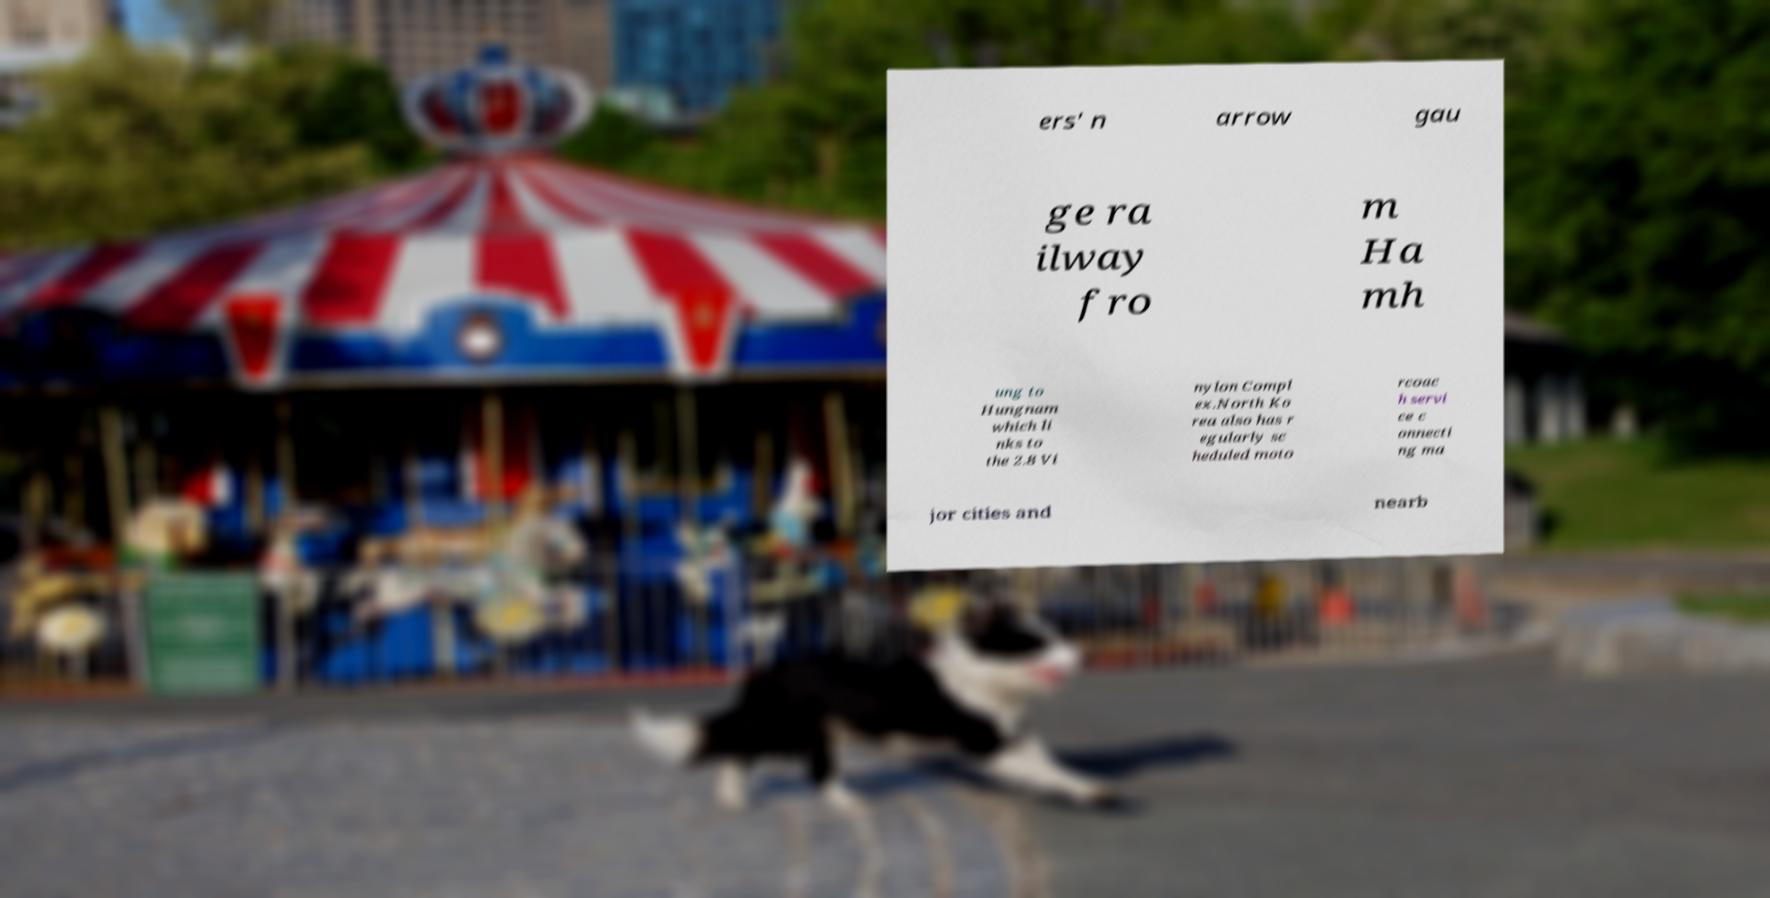Please read and relay the text visible in this image. What does it say? ers' n arrow gau ge ra ilway fro m Ha mh ung to Hungnam which li nks to the 2.8 Vi nylon Compl ex.North Ko rea also has r egularly sc heduled moto rcoac h servi ce c onnecti ng ma jor cities and nearb 